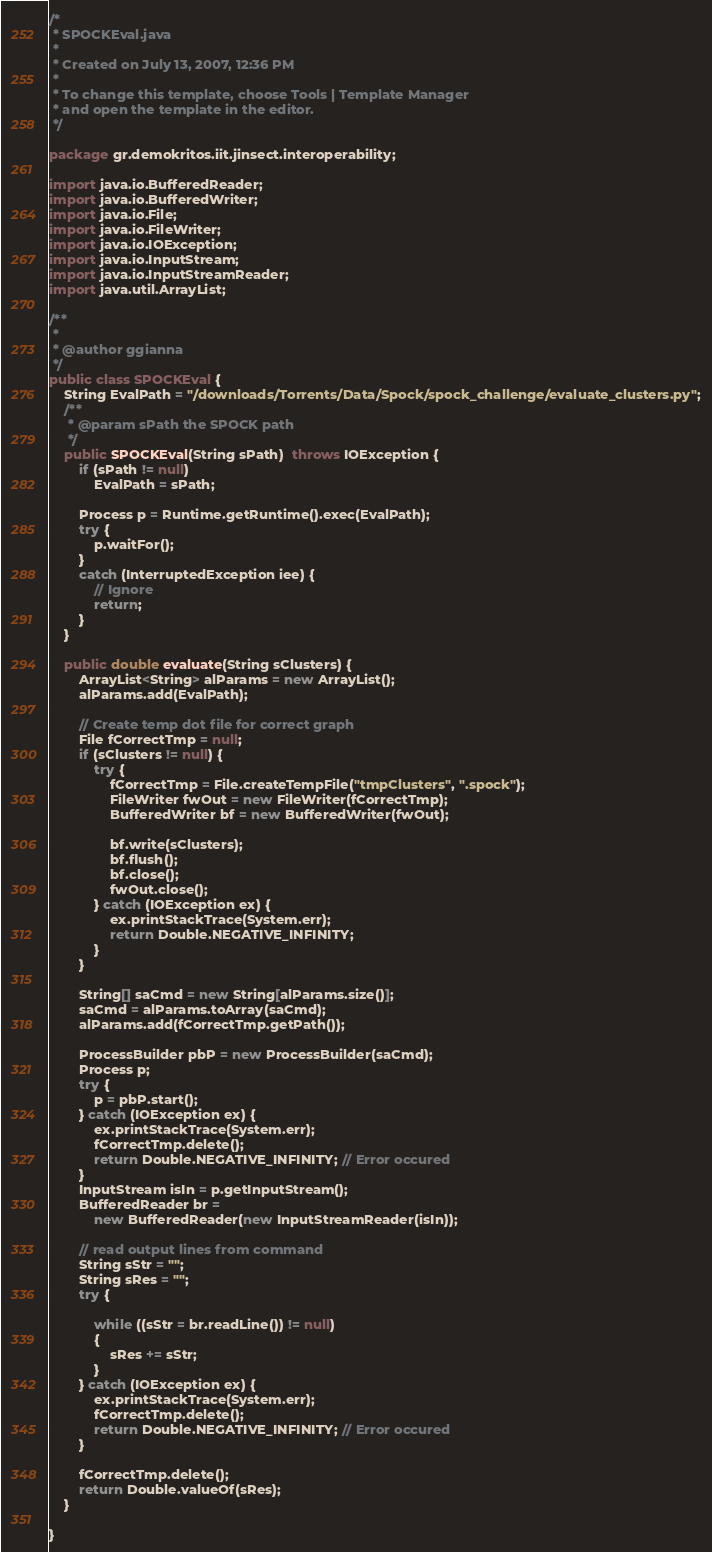<code> <loc_0><loc_0><loc_500><loc_500><_Java_>/*
 * SPOCKEval.java
 *
 * Created on July 13, 2007, 12:36 PM
 *
 * To change this template, choose Tools | Template Manager
 * and open the template in the editor.
 */

package gr.demokritos.iit.jinsect.interoperability;

import java.io.BufferedReader;
import java.io.BufferedWriter;
import java.io.File;
import java.io.FileWriter;
import java.io.IOException;
import java.io.InputStream;
import java.io.InputStreamReader;
import java.util.ArrayList;

/**
 *
 * @author ggianna
 */
public class SPOCKEval {
    String EvalPath = "/downloads/Torrents/Data/Spock/spock_challenge/evaluate_clusters.py";
    /**
     * @param sPath the SPOCK path
     */
    public SPOCKEval(String sPath)  throws IOException {
        if (sPath != null)
            EvalPath = sPath;
        
        Process p = Runtime.getRuntime().exec(EvalPath);
        try {
            p.waitFor();
        }
        catch (InterruptedException iee) {
            // Ignore
            return;
        }
    }
    
    public double evaluate(String sClusters) {
        ArrayList<String> alParams = new ArrayList();
        alParams.add(EvalPath);

        // Create temp dot file for correct graph
        File fCorrectTmp = null;
        if (sClusters != null) {
            try {
                fCorrectTmp = File.createTempFile("tmpClusters", ".spock");
                FileWriter fwOut = new FileWriter(fCorrectTmp);
                BufferedWriter bf = new BufferedWriter(fwOut);
                
                bf.write(sClusters);
                bf.flush();
                bf.close();
                fwOut.close();
            } catch (IOException ex) {
                ex.printStackTrace(System.err);
                return Double.NEGATIVE_INFINITY;
            }
        }
        
        String[] saCmd = new String[alParams.size()];
        saCmd = alParams.toArray(saCmd);
        alParams.add(fCorrectTmp.getPath());

        ProcessBuilder pbP = new ProcessBuilder(saCmd);
        Process p;
        try {
            p = pbP.start();
        } catch (IOException ex) {
            ex.printStackTrace(System.err);
            fCorrectTmp.delete();
            return Double.NEGATIVE_INFINITY; // Error occured
        }
        InputStream isIn = p.getInputStream();        
        BufferedReader br =
            new BufferedReader(new InputStreamReader(isIn));

        // read output lines from command
        String sStr = "";
        String sRes = "";
        try {
            
            while ((sStr = br.readLine()) != null)
            {
                sRes += sStr;
            }
        } catch (IOException ex) {
            ex.printStackTrace(System.err);
            fCorrectTmp.delete();
            return Double.NEGATIVE_INFINITY; // Error occured
        }
        
        fCorrectTmp.delete();
        return Double.valueOf(sRes);
    }
    
}
</code> 